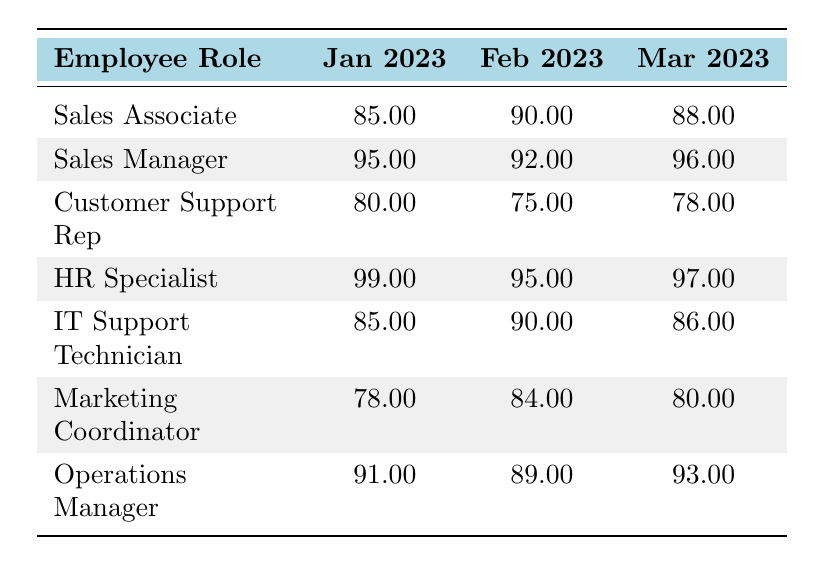What was the training completion rate for Sales Associates in March 2023? In the table, under the "Sales Associate" row, the completion rate for March 2023 is listed as 88.00.
Answer: 88.00 Which employee role had the highest completion rate in January 2023? By comparing the values in the January 2023 column, HR Specialist has the highest completion rate at 99.00.
Answer: HR Specialist What is the average training completion rate for Customer Support Representatives over the three months? The completion rates for Customer Support Representatives are 80.00, 75.00, and 78.00. The sum is (80 + 75 + 78) = 233, and the average is calculated as 233/3 = 77.67.
Answer: 77.67 Did Marketing Coordinators maintain a completion rate above 80.00 in every month? In January, the rate is 78.00 (below 80), February is 84.00 (above 80), and March is 80.00 (equal to 80). Therefore, they did not maintain above 80.00 in every month.
Answer: No What are the completion rates for IT Support Technicians over the three months? The IT Support Technician rates are 85.00 in January, 90.00 in February, and 86.00 in March as seen in the respective rows and columns.
Answer: 85.00, 90.00, 86.00 Which role improved the most from January to March 2023? The Sales Manager's completion rate increased from 95.00 in January to 96.00 in March, while others either decreased or had smaller increases. The largest increase came from Customer Support (80.00 to 78.00, which is actually a decrease). Thus, the Sales Manager improved the most.
Answer: Sales Manager What is the difference in completion rates between HR Specialists and Sales Associates in February 2023? The completion rates in February 2023 are 95.00 for HR Specialists and 90.00 for Sales Associates. The difference is 95.00 - 90.00 = 5.00.
Answer: 5.00 Did any employee roles have a training completion rate of 90 or above in all three months? By reviewing the table, HR specialists had completion rates of 99.00, 95.00, and 97.00, all above 90. However, Sales Manager also achieved this (95.00, 92.00, 96.00).
Answer: Yes 